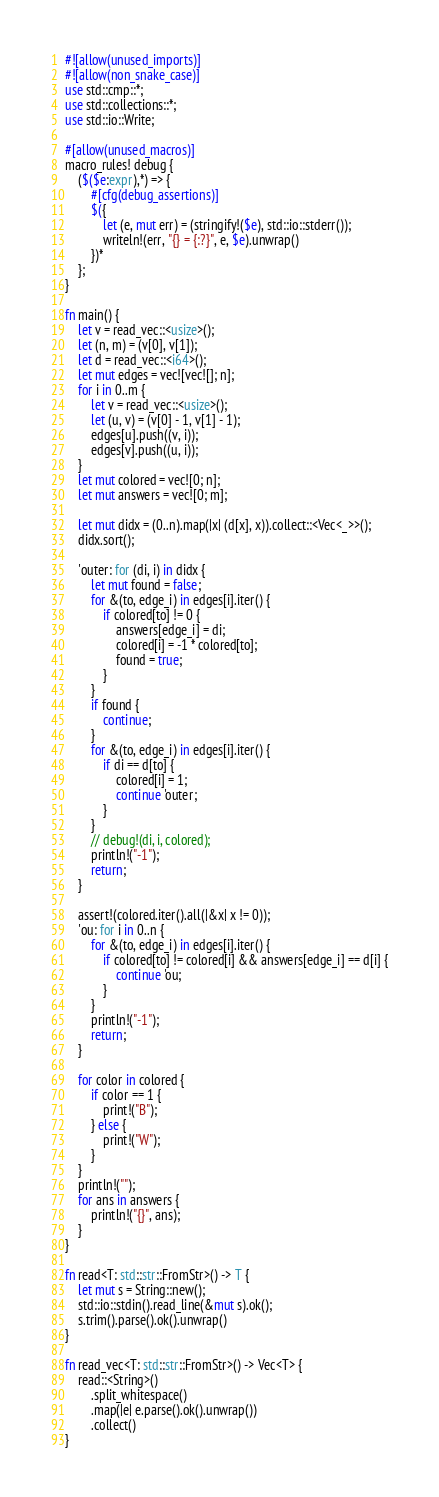<code> <loc_0><loc_0><loc_500><loc_500><_Rust_>#![allow(unused_imports)]
#![allow(non_snake_case)]
use std::cmp::*;
use std::collections::*;
use std::io::Write;

#[allow(unused_macros)]
macro_rules! debug {
    ($($e:expr),*) => {
        #[cfg(debug_assertions)]
        $({
            let (e, mut err) = (stringify!($e), std::io::stderr());
            writeln!(err, "{} = {:?}", e, $e).unwrap()
        })*
    };
}

fn main() {
    let v = read_vec::<usize>();
    let (n, m) = (v[0], v[1]);
    let d = read_vec::<i64>();
    let mut edges = vec![vec![]; n];
    for i in 0..m {
        let v = read_vec::<usize>();
        let (u, v) = (v[0] - 1, v[1] - 1);
        edges[u].push((v, i));
        edges[v].push((u, i));
    }
    let mut colored = vec![0; n];
    let mut answers = vec![0; m];

    let mut didx = (0..n).map(|x| (d[x], x)).collect::<Vec<_>>();
    didx.sort();

    'outer: for (di, i) in didx {
        let mut found = false;
        for &(to, edge_i) in edges[i].iter() {
            if colored[to] != 0 {
                answers[edge_i] = di;
                colored[i] = -1 * colored[to];
                found = true;
            }
        }
        if found {
            continue;
        }
        for &(to, edge_i) in edges[i].iter() {
            if di == d[to] {
                colored[i] = 1;
                continue 'outer;
            }
        }
        // debug!(di, i, colored);
        println!("-1");
        return;
    }

    assert!(colored.iter().all(|&x| x != 0));
    'ou: for i in 0..n {
        for &(to, edge_i) in edges[i].iter() {
            if colored[to] != colored[i] && answers[edge_i] == d[i] {
                continue 'ou;
            }
        }
        println!("-1");
        return;
    }

    for color in colored {
        if color == 1 {
            print!("B");
        } else {
            print!("W");
        }
    }
    println!("");
    for ans in answers {
        println!("{}", ans);
    }
}

fn read<T: std::str::FromStr>() -> T {
    let mut s = String::new();
    std::io::stdin().read_line(&mut s).ok();
    s.trim().parse().ok().unwrap()
}

fn read_vec<T: std::str::FromStr>() -> Vec<T> {
    read::<String>()
        .split_whitespace()
        .map(|e| e.parse().ok().unwrap())
        .collect()
}
</code> 